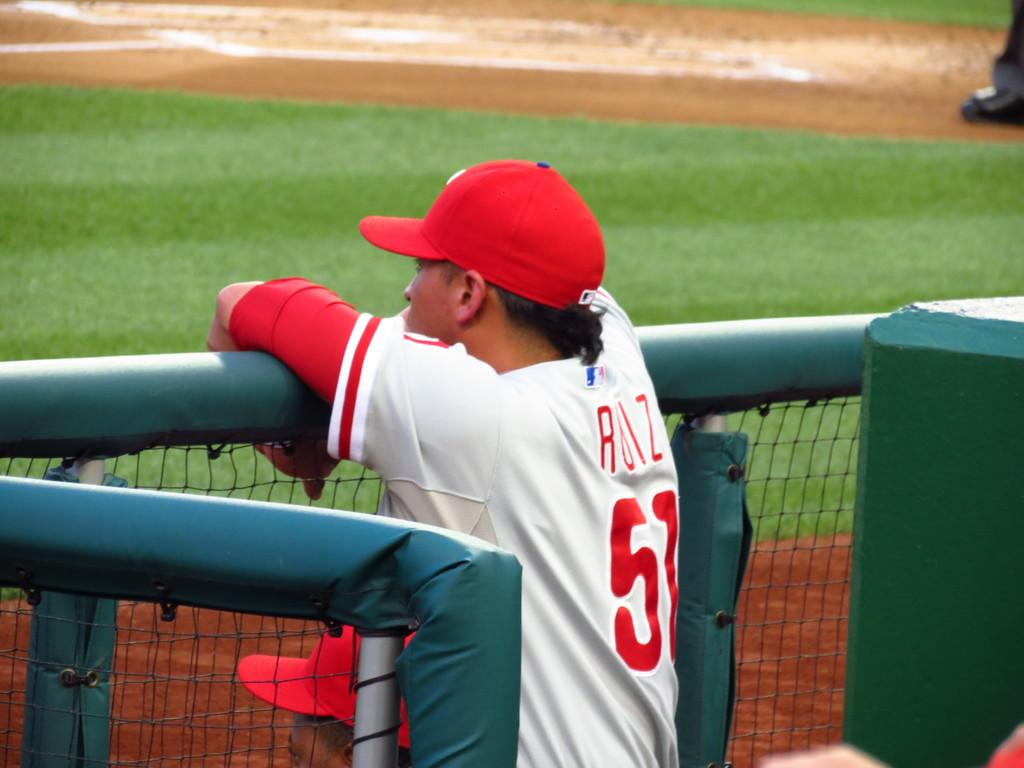<image>
Present a compact description of the photo's key features. A baseball player wearing the number 57 is peering over a fence. 